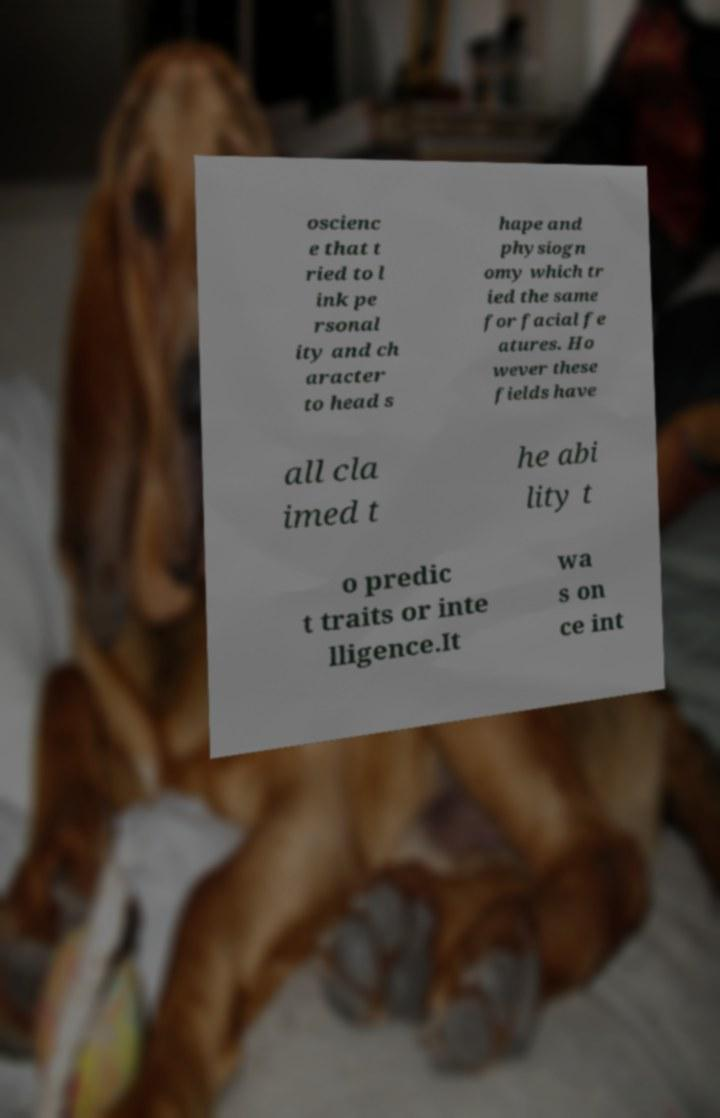Could you extract and type out the text from this image? oscienc e that t ried to l ink pe rsonal ity and ch aracter to head s hape and physiogn omy which tr ied the same for facial fe atures. Ho wever these fields have all cla imed t he abi lity t o predic t traits or inte lligence.It wa s on ce int 